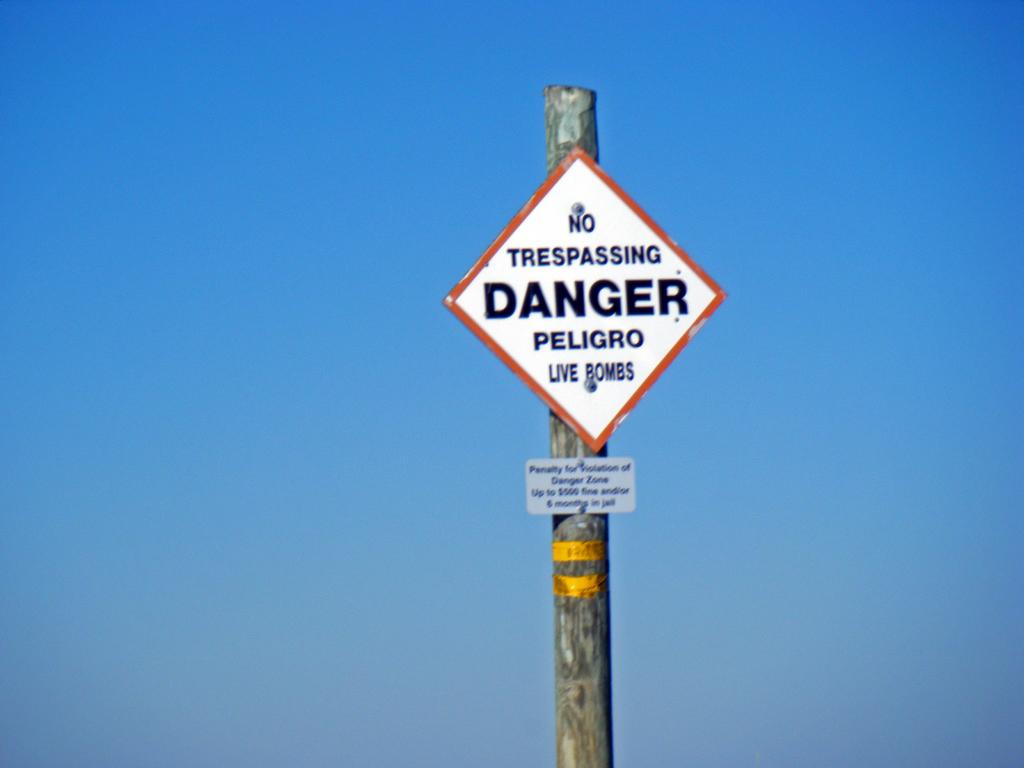What is the sign warning people of?
Keep it short and to the point. Live bombs. What should you not do here?
Your answer should be compact. Trespass. 